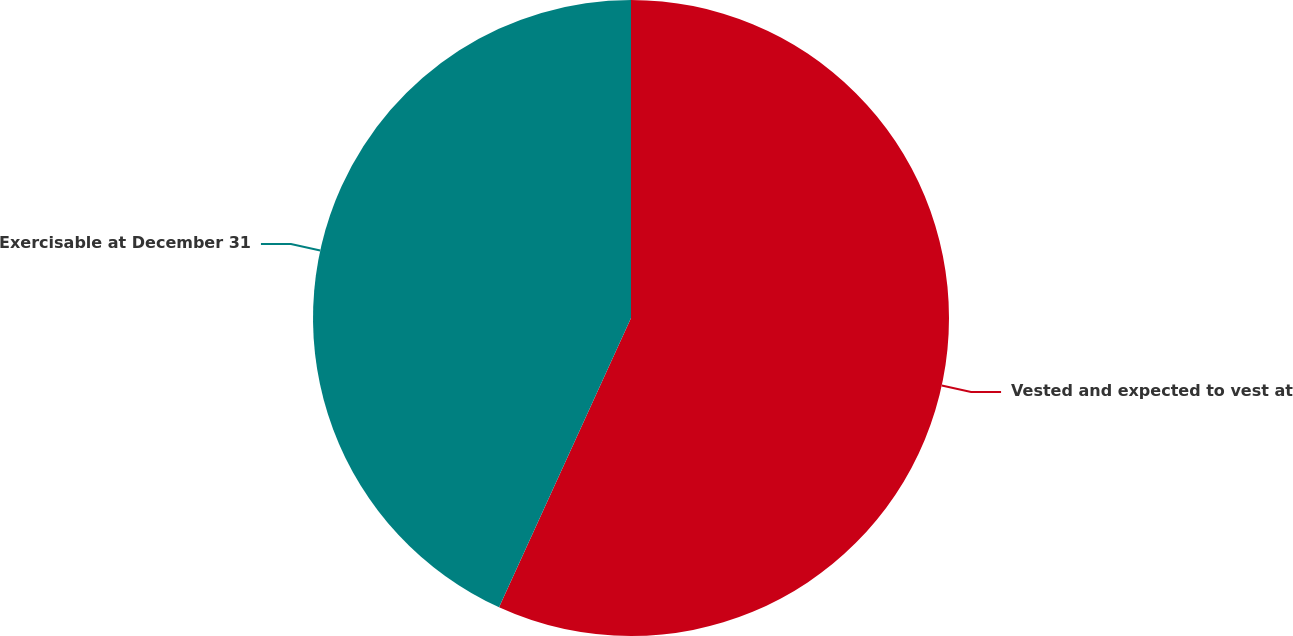Convert chart to OTSL. <chart><loc_0><loc_0><loc_500><loc_500><pie_chart><fcel>Vested and expected to vest at<fcel>Exercisable at December 31<nl><fcel>56.81%<fcel>43.19%<nl></chart> 